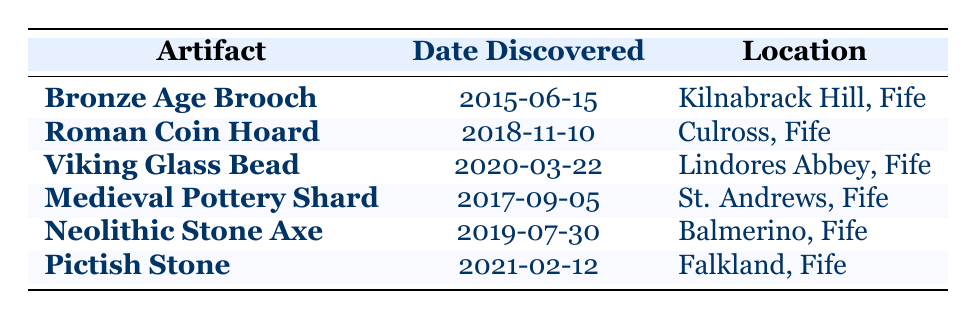What is the location of the Bronze Age Brooch? The table lists the Bronze Age Brooch under the "Location" column, which states that it was discovered at Kilnabrack Hill, Fife.
Answer: Kilnabrack Hill, Fife Which artifact was discovered the earliest? The table shows that the earliest artifact listed is the Bronze Age Brooch, with a discovery date of 2015-06-15, as this date is before all other entries.
Answer: Bronze Age Brooch Was the Roman Coin Hoard discovered before 2020? The Roman Coin Hoard has a discovery date of 2018-11-10, which is indeed before 2020, making the statement true.
Answer: Yes What is the date of the Neolithic Stone Axe’s discovery? The Neolithic Stone Axe has a specific entry in the table indicating its discovery date as 2019-07-30.
Answer: 2019-07-30 Which artifacts were discovered in the year 2018? Referring to the table, the artifact listed for the year 2018 is the Roman Coin Hoard, with a discovery date of 2018-11-10, and there are no other entries for that year.
Answer: Roman Coin Hoard How many years apart were the discoveries of the Viking Glass Bead and the Pictish Stone? The Viking Glass Bead was discovered on 2020-03-22 and the Pictish Stone on 2021-02-12. Calculating the difference between these two dates shows that they were discovered approximately 11 months apart.
Answer: 11 months Was there a discovery in Balmerino? In the "Location" column, the table lists the Neolithic Stone Axe as being discovered in Balmerino, confirming the statement as true.
Answer: Yes What is the most recent artifact discovered according to the table? The most recent entry in the table is for the Pictish Stone, discovered on 2021-02-12, making it the latest artifact listed.
Answer: Pictish Stone How many artifacts were discovered between 2015 and 2019 inclusive? The table lists the artifacts discovered from 2015 (Bronze Age Brooch) to 2019 (Neolithic Stone Axe). The total number of artifacts during this period is 5, as there are 5 entries covering these years.
Answer: 5 